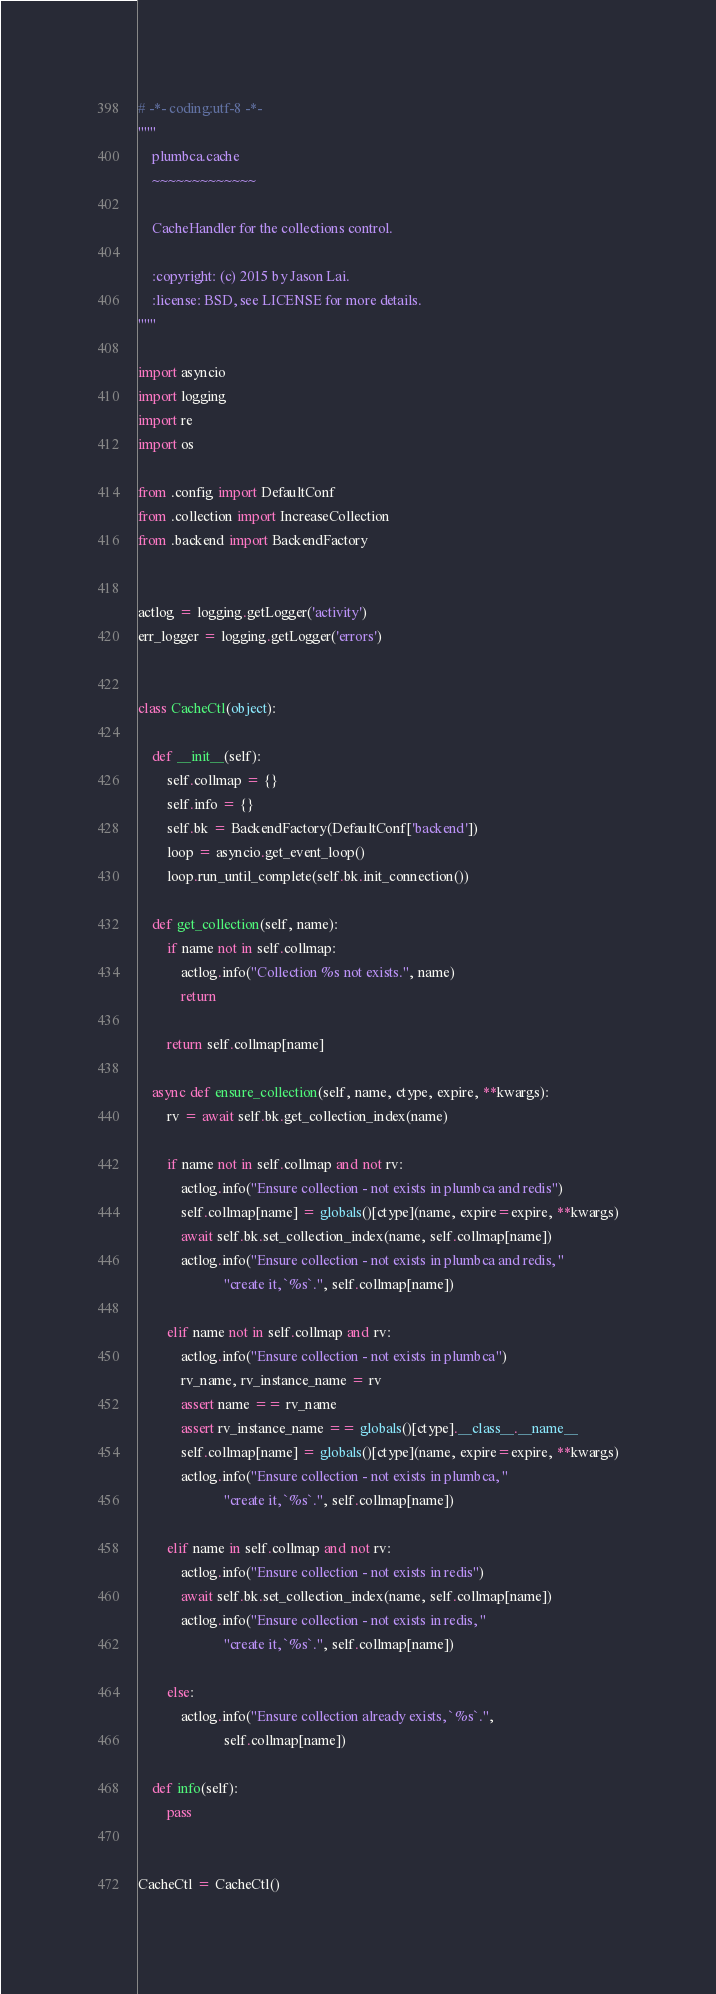<code> <loc_0><loc_0><loc_500><loc_500><_Python_># -*- coding:utf-8 -*-
"""
    plumbca.cache
    ~~~~~~~~~~~~~

    CacheHandler for the collections control.

    :copyright: (c) 2015 by Jason Lai.
    :license: BSD, see LICENSE for more details.
"""

import asyncio
import logging
import re
import os

from .config import DefaultConf
from .collection import IncreaseCollection
from .backend import BackendFactory


actlog = logging.getLogger('activity')
err_logger = logging.getLogger('errors')


class CacheCtl(object):

    def __init__(self):
        self.collmap = {}
        self.info = {}
        self.bk = BackendFactory(DefaultConf['backend'])
        loop = asyncio.get_event_loop()
        loop.run_until_complete(self.bk.init_connection())

    def get_collection(self, name):
        if name not in self.collmap:
            actlog.info("Collection %s not exists.", name)
            return

        return self.collmap[name]

    async def ensure_collection(self, name, ctype, expire, **kwargs):
        rv = await self.bk.get_collection_index(name)

        if name not in self.collmap and not rv:
            actlog.info("Ensure collection - not exists in plumbca and redis")
            self.collmap[name] = globals()[ctype](name, expire=expire, **kwargs)
            await self.bk.set_collection_index(name, self.collmap[name])
            actlog.info("Ensure collection - not exists in plumbca and redis, "
                        "create it, `%s`.", self.collmap[name])

        elif name not in self.collmap and rv:
            actlog.info("Ensure collection - not exists in plumbca")
            rv_name, rv_instance_name = rv
            assert name == rv_name
            assert rv_instance_name == globals()[ctype].__class__.__name__
            self.collmap[name] = globals()[ctype](name, expire=expire, **kwargs)
            actlog.info("Ensure collection - not exists in plumbca, "
                        "create it, `%s`.", self.collmap[name])

        elif name in self.collmap and not rv:
            actlog.info("Ensure collection - not exists in redis")
            await self.bk.set_collection_index(name, self.collmap[name])
            actlog.info("Ensure collection - not exists in redis, "
                        "create it, `%s`.", self.collmap[name])

        else:
            actlog.info("Ensure collection already exists, `%s`.",
                        self.collmap[name])

    def info(self):
        pass


CacheCtl = CacheCtl()
</code> 